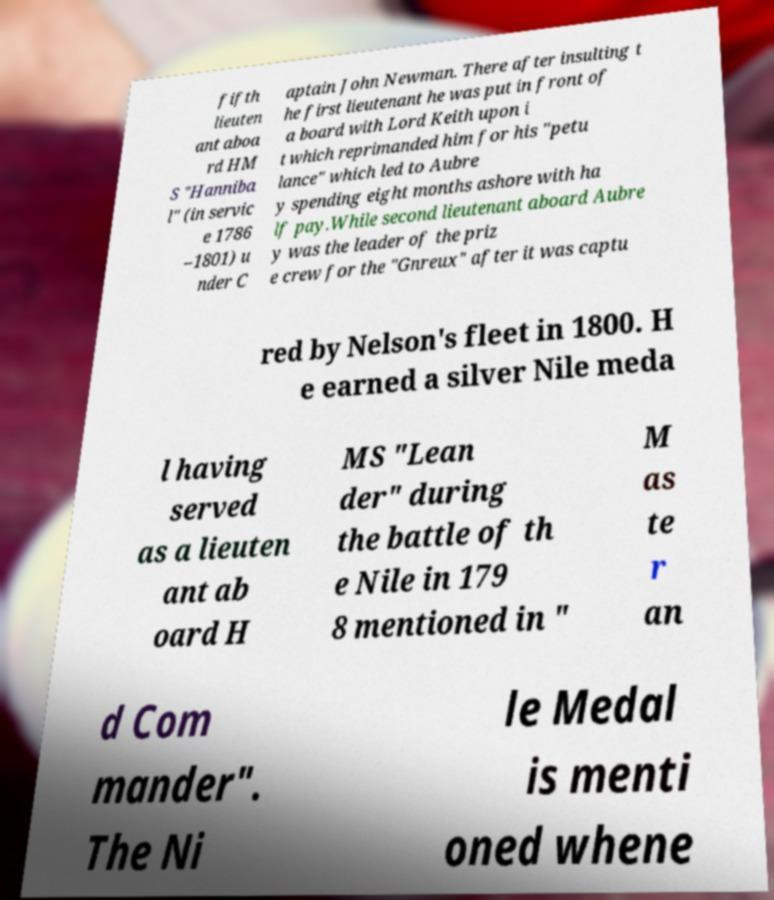Can you read and provide the text displayed in the image?This photo seems to have some interesting text. Can you extract and type it out for me? fifth lieuten ant aboa rd HM S "Hanniba l" (in servic e 1786 –1801) u nder C aptain John Newman. There after insulting t he first lieutenant he was put in front of a board with Lord Keith upon i t which reprimanded him for his "petu lance" which led to Aubre y spending eight months ashore with ha lf pay.While second lieutenant aboard Aubre y was the leader of the priz e crew for the "Gnreux" after it was captu red by Nelson's fleet in 1800. H e earned a silver Nile meda l having served as a lieuten ant ab oard H MS "Lean der" during the battle of th e Nile in 179 8 mentioned in " M as te r an d Com mander". The Ni le Medal is menti oned whene 